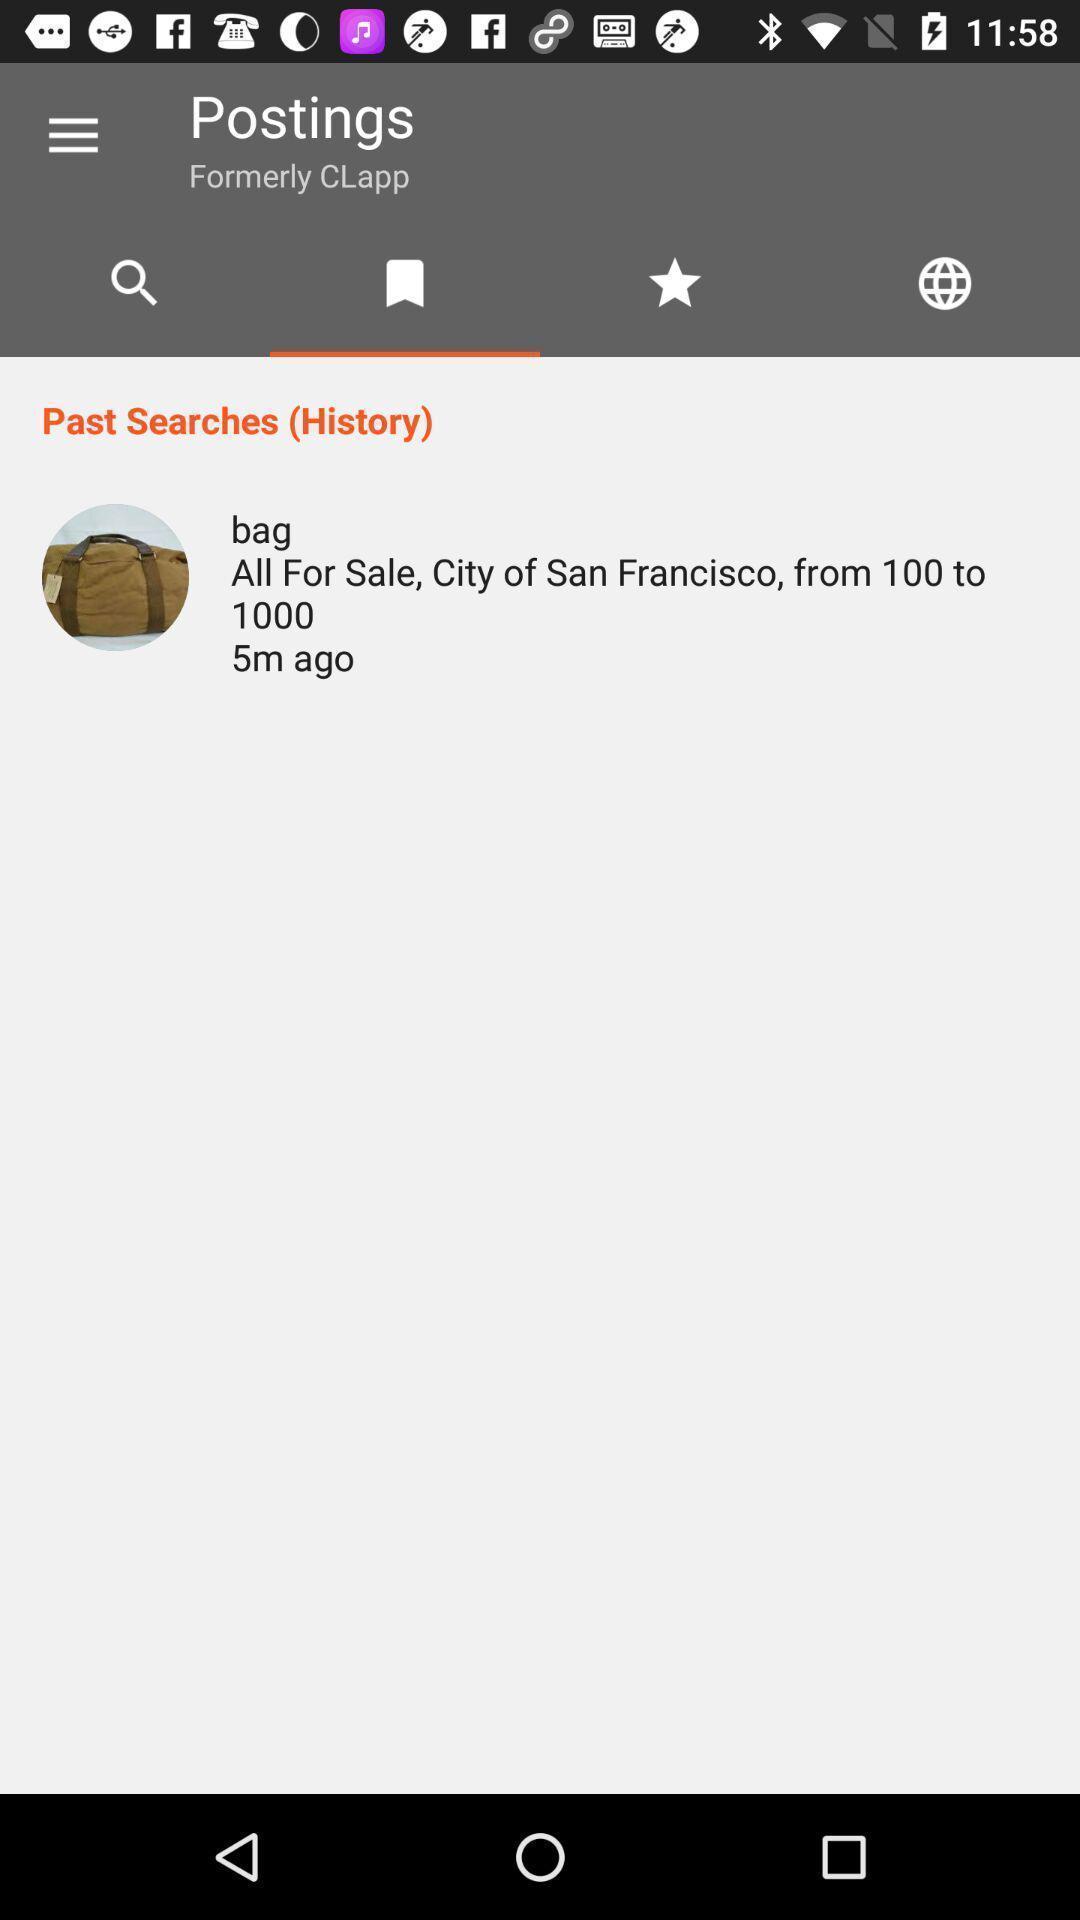Describe the visual elements of this screenshot. Search history page of a business app. 